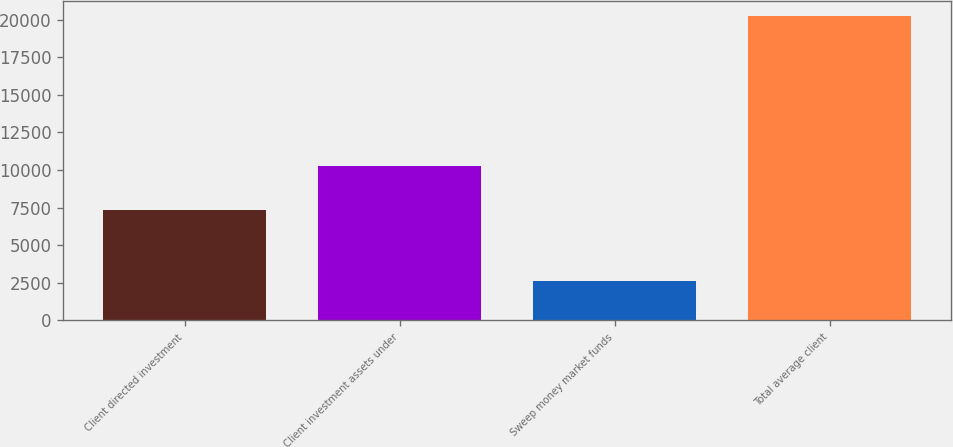<chart> <loc_0><loc_0><loc_500><loc_500><bar_chart><fcel>Client directed investment<fcel>Client investment assets under<fcel>Sweep money market funds<fcel>Total average client<nl><fcel>7335<fcel>10282<fcel>2596<fcel>20213<nl></chart> 